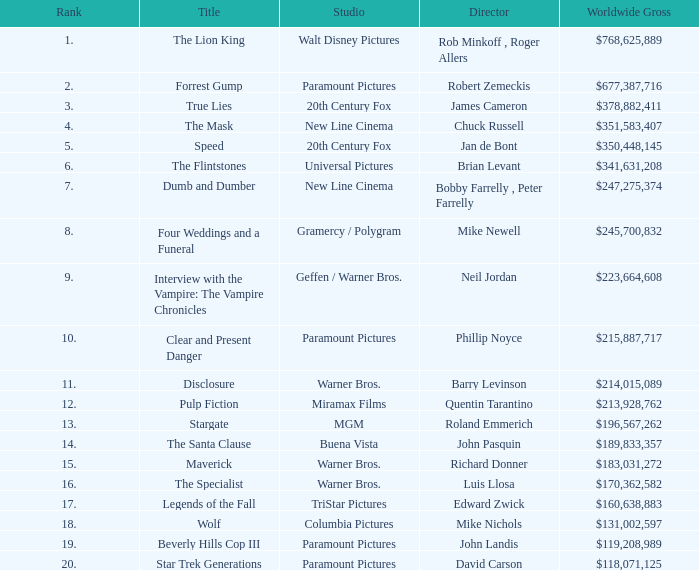What is the Worldwide Gross of the Film with a Rank of 3? $378,882,411. 